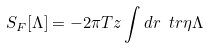Convert formula to latex. <formula><loc_0><loc_0><loc_500><loc_500>S _ { F } [ \Lambda ] = - 2 \pi T z \int d r \ t r \eta \Lambda</formula> 